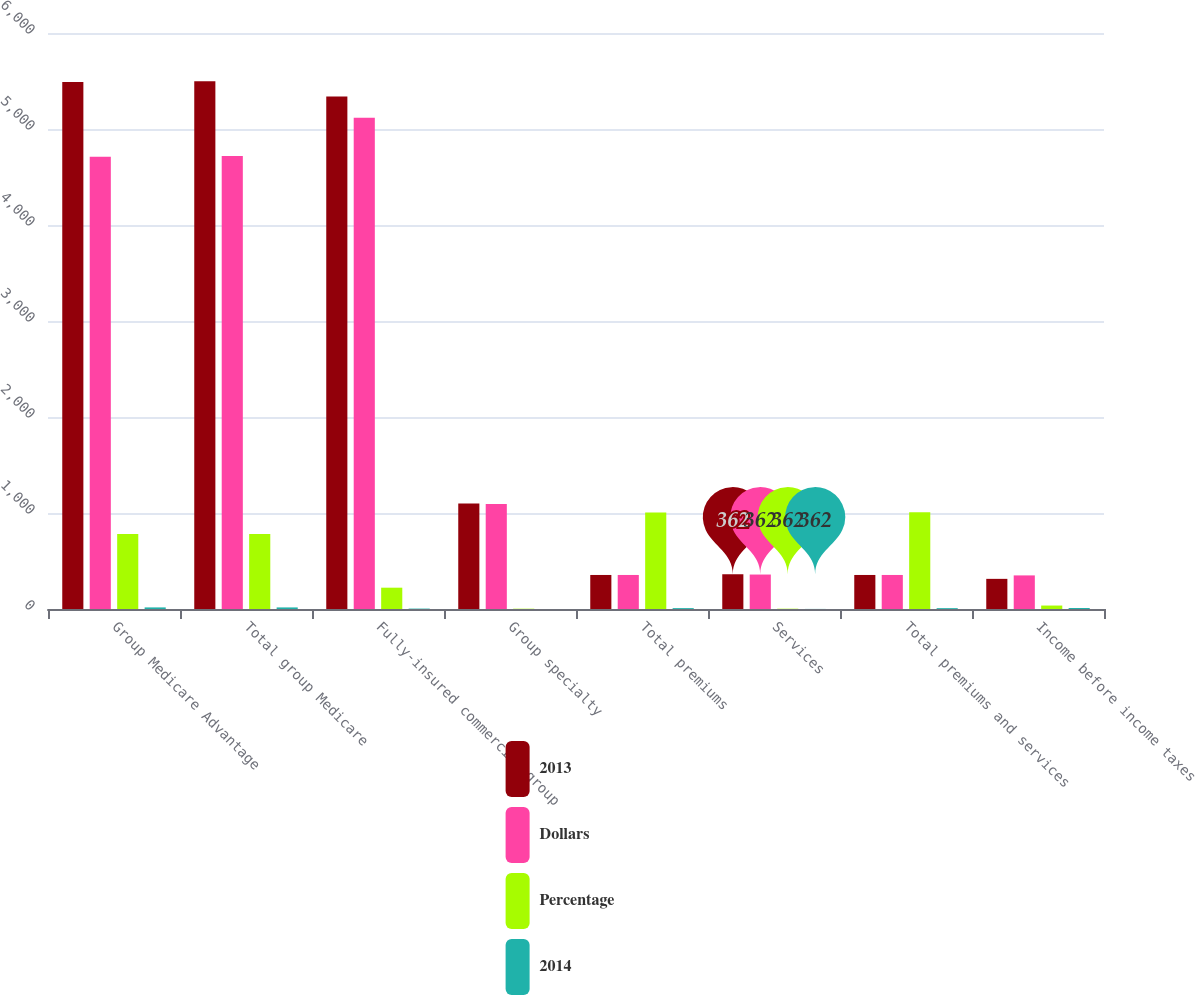<chart> <loc_0><loc_0><loc_500><loc_500><stacked_bar_chart><ecel><fcel>Group Medicare Advantage<fcel>Total group Medicare<fcel>Fully-insured commercial group<fcel>Group specialty<fcel>Total premiums<fcel>Services<fcel>Total premiums and services<fcel>Income before income taxes<nl><fcel>2013<fcel>5490<fcel>5498<fcel>5339<fcel>1098<fcel>354.5<fcel>362<fcel>354.5<fcel>314<nl><fcel>Dollars<fcel>4710<fcel>4718<fcel>5117<fcel>1095<fcel>354.5<fcel>359<fcel>354.5<fcel>350<nl><fcel>Percentage<fcel>780<fcel>780<fcel>222<fcel>3<fcel>1005<fcel>3<fcel>1008<fcel>36<nl><fcel>2014<fcel>16.6<fcel>16.5<fcel>4.3<fcel>0.3<fcel>9.2<fcel>0.8<fcel>8.9<fcel>10.3<nl></chart> 